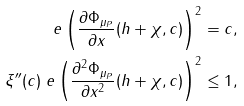<formula> <loc_0><loc_0><loc_500><loc_500>\ e \left ( \frac { \partial \Phi _ { \mu _ { P } } } { \partial x } ( h + \chi , c ) \right ) ^ { 2 } & = c , \\ \xi ^ { \prime \prime } ( c ) \ e \left ( \frac { \partial ^ { 2 } \Phi _ { \mu _ { P } } } { \partial x ^ { 2 } } ( h + \chi , c ) \right ) ^ { 2 } & \leq 1 ,</formula> 